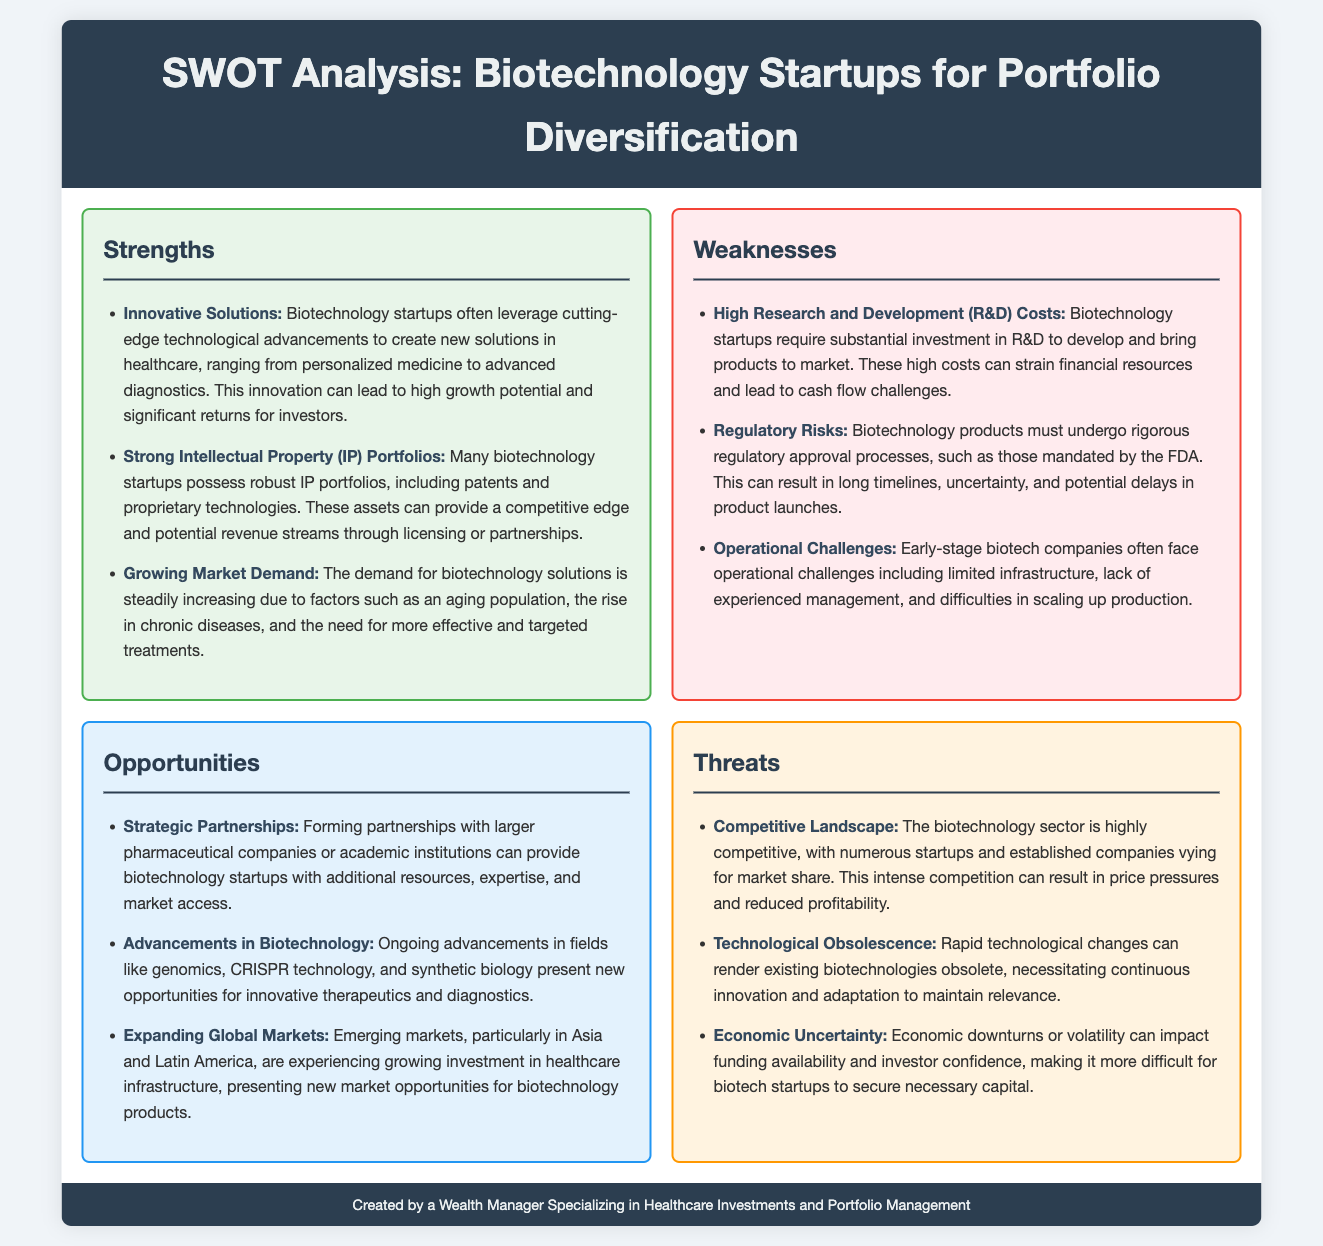what is one strength of biotechnology startups? The document lists "Innovative Solutions" as one of the strengths of biotechnology startups.
Answer: Innovative Solutions what is a significant weakness faced by biotechnology startups? One of the weaknesses mentioned in the document is "High Research and Development (R&D) Costs."
Answer: High Research and Development (R&D) Costs what opportunity involves collaboration with larger companies? The document states "Strategic Partnerships" as an opportunity for biotechnology startups.
Answer: Strategic Partnerships what is a notable threat in the biotechnology sector? The document highlights "Competitive Landscape" as a notable threat facing biotechnology startups.
Answer: Competitive Landscape how many strengths are listed in the document? The document includes three strengths outlined under the strengths section.
Answer: 3 what is one factor driving market demand for biotechnology solutions? The document mentions the "aging population" as a factor driving demand in the healthcare market.
Answer: aging population what type of advancements are creating new opportunities in biotechnology? The document refers to "Advancements in Biotechnology" such as genomics and CRISPR technology as creating new opportunities.
Answer: Advancements in Biotechnology which market is mentioned as expanding for biotechnology products? The document states "Emerging markets" as an area with expanding opportunities for biotechnology.
Answer: Emerging markets 